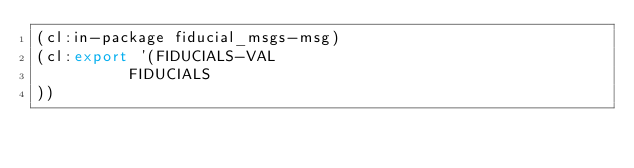<code> <loc_0><loc_0><loc_500><loc_500><_Lisp_>(cl:in-package fiducial_msgs-msg)
(cl:export '(FIDUCIALS-VAL
          FIDUCIALS
))</code> 